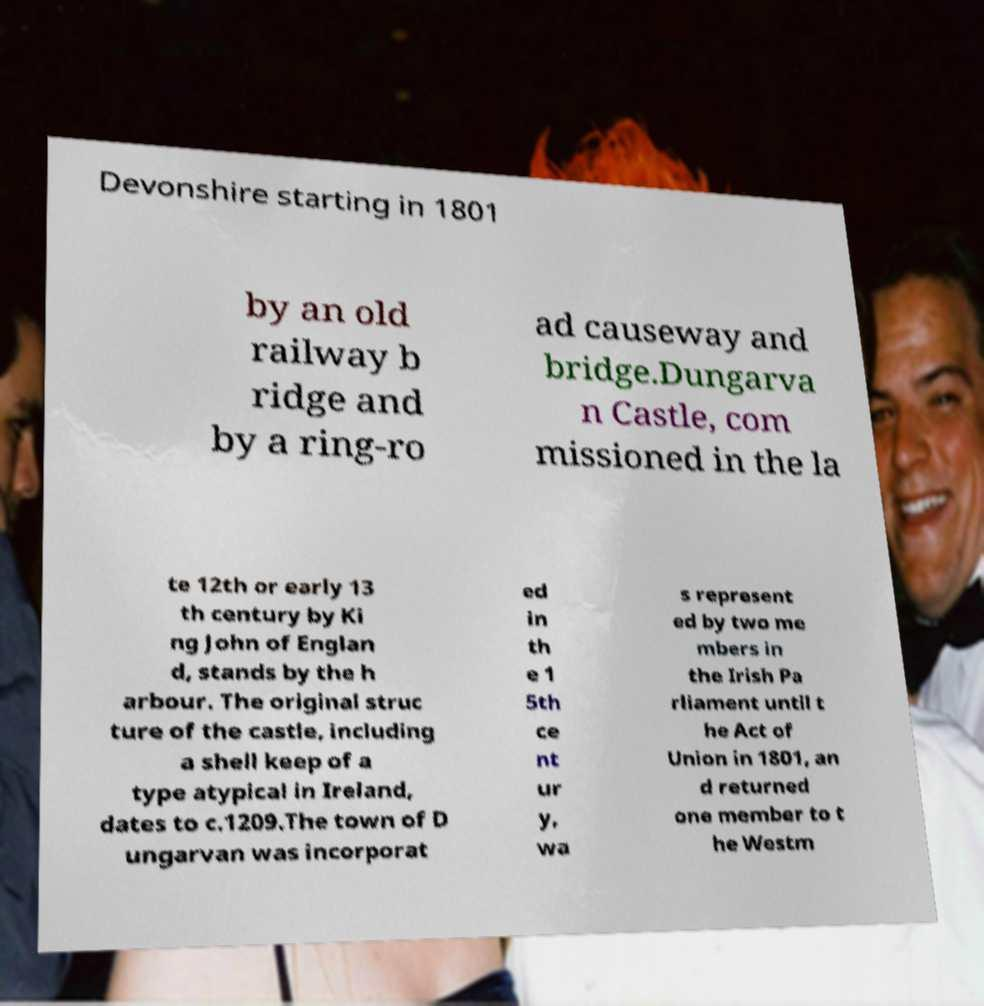Can you accurately transcribe the text from the provided image for me? Devonshire starting in 1801 by an old railway b ridge and by a ring-ro ad causeway and bridge.Dungarva n Castle, com missioned in the la te 12th or early 13 th century by Ki ng John of Englan d, stands by the h arbour. The original struc ture of the castle, including a shell keep of a type atypical in Ireland, dates to c.1209.The town of D ungarvan was incorporat ed in th e 1 5th ce nt ur y, wa s represent ed by two me mbers in the Irish Pa rliament until t he Act of Union in 1801, an d returned one member to t he Westm 